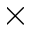<formula> <loc_0><loc_0><loc_500><loc_500>\times</formula> 